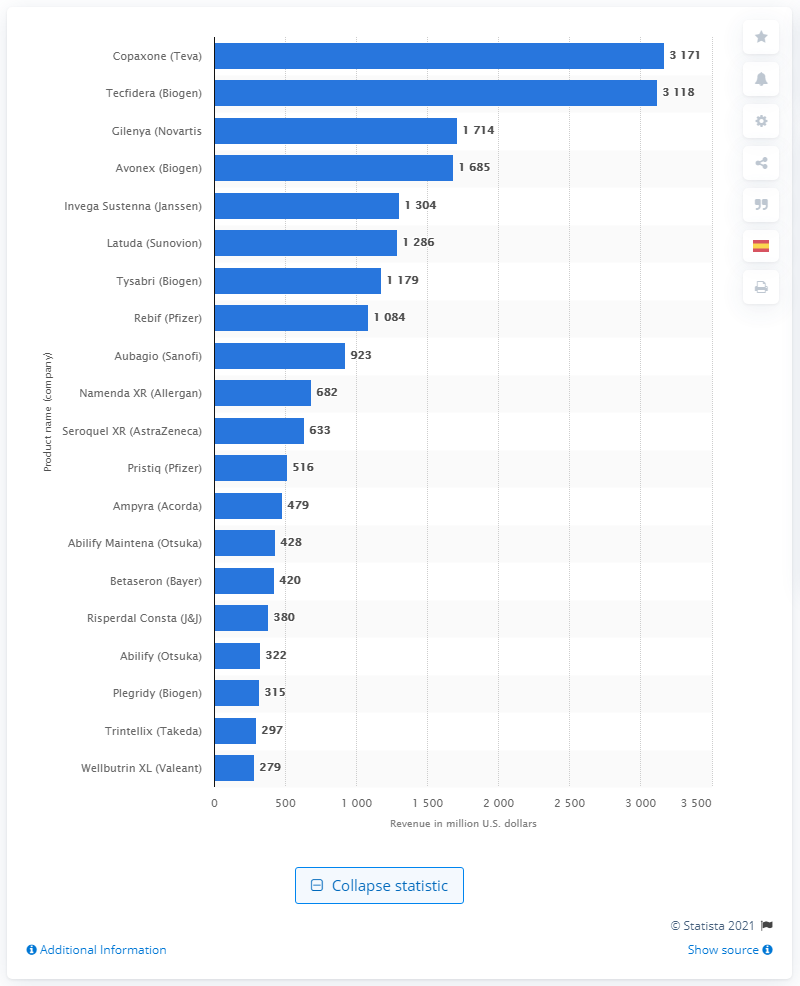Point out several critical features in this image. It is projected that Abilify will generate approximately 322 million dollars in the United States in 2016. The decrease in revenues for Abilify from 2014 to 2015 was 1714. 